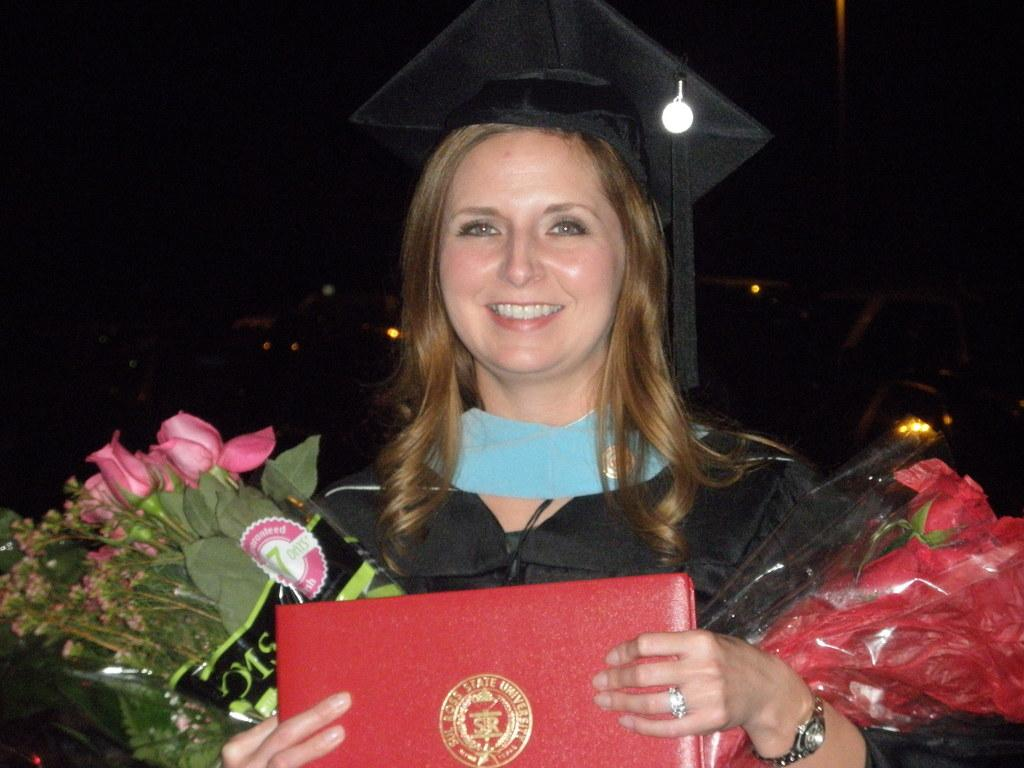What is present in the image? There is a person in the image. Can you describe the person's attire? The person is wearing clothes and a hat. What is the person holding in their hands? The person is holding a file and bouquets. How many flesh-colored balls are visible in the image? There are no flesh-colored balls present in the image. What type of clocks can be seen hanging on the person's hat? There are no clocks visible on the person's hat in the image. 